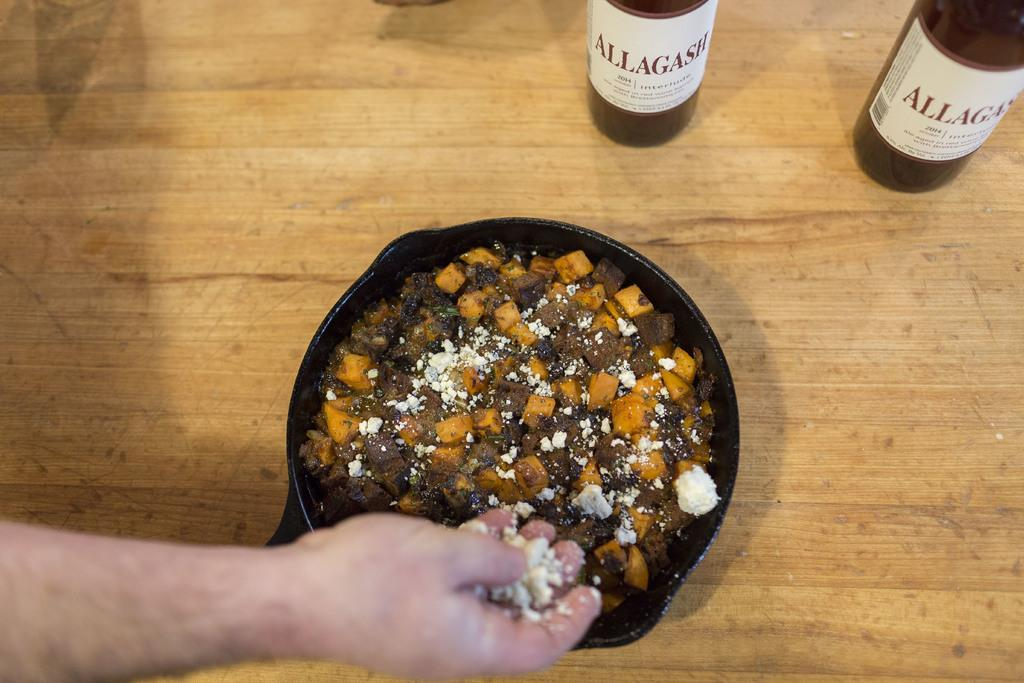<image>
Provide a brief description of the given image. A person adds cheese to a dish next to bottles of 2014 Allagash. 